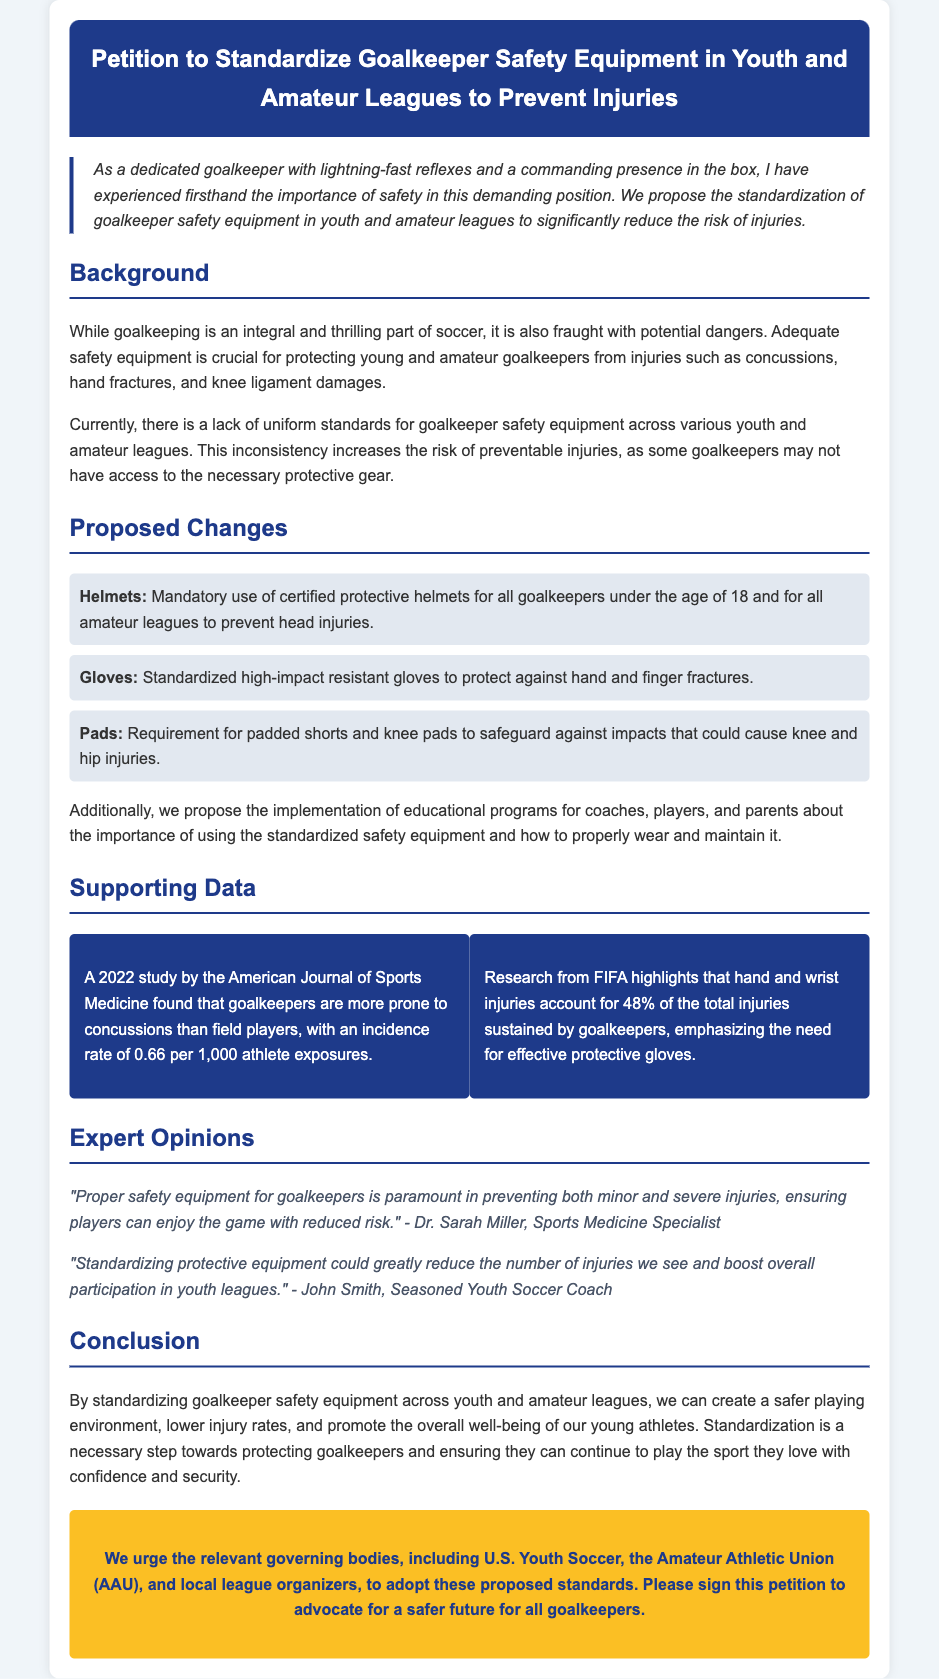What is the title of the petition? The title of the petition is clearly stated at the top of the document.
Answer: Petition to Standardize Goalkeeper Safety Equipment in Youth and Amateur Leagues to Prevent Injuries What is the main purpose of the petition? The main purpose is outlined in the introduction, focusing on safety for goalkeepers.
Answer: To significantly reduce the risk of injuries How many types of safety equipment are proposed in the petition? The document lists three distinct types of safety equipment being proposed.
Answer: Three What percentage of injuries among goalkeepers are hand and wrist injuries according to FIFA? The document provides specific statistics regarding injury types, highlighting the significant percentage.
Answer: 48% Who is the sports medicine specialist quoted in the expert opinions? The document includes an expert opinion along with the name of the specialist offered.
Answer: Dr. Sarah Miller What study is cited regarding concussions among goalkeepers? A study is referenced in the supporting data section, highlighting the issue of concussions.
Answer: A 2022 study by the American Journal of Sports Medicine What is the call to action at the end of the petition? The last section encourages the audience to take a specific action in support of the petition.
Answer: Please sign this petition Why is standardization of goalkeeper safety equipment important? The conclusion summarizes the main reasons for the proposal, emphasizing safety and participation.
Answer: Creating a safer playing environment 